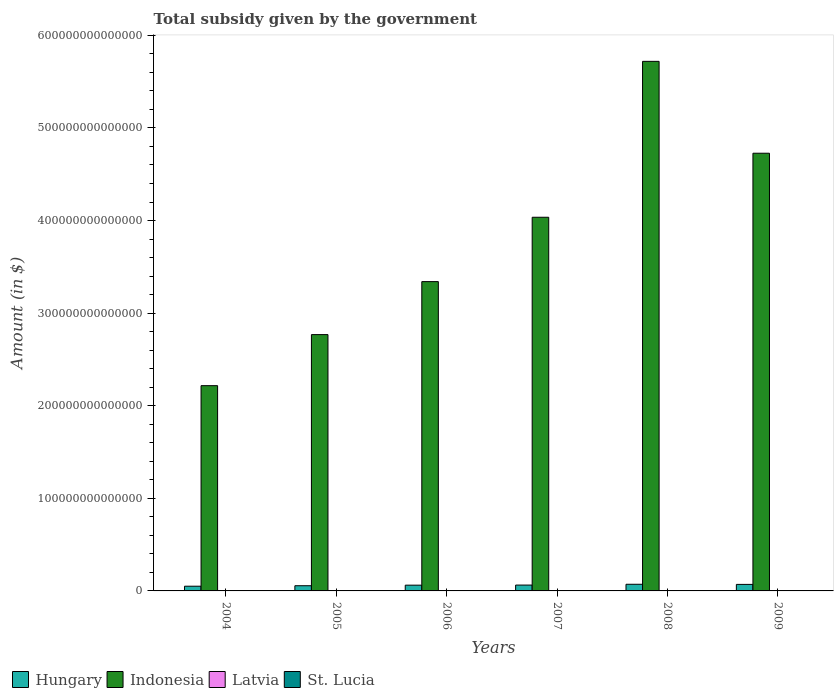How many different coloured bars are there?
Give a very brief answer. 4. Are the number of bars per tick equal to the number of legend labels?
Provide a short and direct response. Yes. How many bars are there on the 3rd tick from the left?
Ensure brevity in your answer.  4. How many bars are there on the 3rd tick from the right?
Your answer should be compact. 4. In how many cases, is the number of bars for a given year not equal to the number of legend labels?
Ensure brevity in your answer.  0. What is the total revenue collected by the government in St. Lucia in 2005?
Your answer should be compact. 9.65e+07. Across all years, what is the maximum total revenue collected by the government in St. Lucia?
Give a very brief answer. 1.28e+08. Across all years, what is the minimum total revenue collected by the government in Hungary?
Your response must be concise. 5.09e+12. In which year was the total revenue collected by the government in Indonesia maximum?
Ensure brevity in your answer.  2008. In which year was the total revenue collected by the government in Hungary minimum?
Offer a very short reply. 2004. What is the total total revenue collected by the government in St. Lucia in the graph?
Provide a succinct answer. 5.50e+08. What is the difference between the total revenue collected by the government in St. Lucia in 2004 and that in 2009?
Provide a succinct answer. -2.20e+07. What is the difference between the total revenue collected by the government in St. Lucia in 2005 and the total revenue collected by the government in Latvia in 2004?
Make the answer very short. -8.12e+08. What is the average total revenue collected by the government in Hungary per year?
Give a very brief answer. 6.24e+12. In the year 2006, what is the difference between the total revenue collected by the government in Hungary and total revenue collected by the government in Indonesia?
Give a very brief answer. -3.28e+14. What is the ratio of the total revenue collected by the government in St. Lucia in 2007 to that in 2009?
Provide a short and direct response. 0.35. What is the difference between the highest and the second highest total revenue collected by the government in Hungary?
Provide a succinct answer. 1.41e+11. What is the difference between the highest and the lowest total revenue collected by the government in St. Lucia?
Provide a succinct answer. 8.26e+07. In how many years, is the total revenue collected by the government in Latvia greater than the average total revenue collected by the government in Latvia taken over all years?
Offer a very short reply. 3. Is the sum of the total revenue collected by the government in Indonesia in 2008 and 2009 greater than the maximum total revenue collected by the government in Latvia across all years?
Give a very brief answer. Yes. What does the 2nd bar from the left in 2007 represents?
Make the answer very short. Indonesia. What does the 1st bar from the right in 2008 represents?
Ensure brevity in your answer.  St. Lucia. Is it the case that in every year, the sum of the total revenue collected by the government in Indonesia and total revenue collected by the government in Latvia is greater than the total revenue collected by the government in St. Lucia?
Provide a short and direct response. Yes. How many years are there in the graph?
Provide a succinct answer. 6. What is the difference between two consecutive major ticks on the Y-axis?
Your response must be concise. 1.00e+14. Does the graph contain any zero values?
Your answer should be compact. No. Where does the legend appear in the graph?
Offer a very short reply. Bottom left. How many legend labels are there?
Offer a very short reply. 4. What is the title of the graph?
Your answer should be very brief. Total subsidy given by the government. What is the label or title of the Y-axis?
Ensure brevity in your answer.  Amount (in $). What is the Amount (in $) of Hungary in 2004?
Keep it short and to the point. 5.09e+12. What is the Amount (in $) of Indonesia in 2004?
Keep it short and to the point. 2.22e+14. What is the Amount (in $) in Latvia in 2004?
Your response must be concise. 9.08e+08. What is the Amount (in $) of St. Lucia in 2004?
Give a very brief answer. 1.06e+08. What is the Amount (in $) in Hungary in 2005?
Your response must be concise. 5.60e+12. What is the Amount (in $) in Indonesia in 2005?
Provide a succinct answer. 2.77e+14. What is the Amount (in $) in Latvia in 2005?
Provide a succinct answer. 1.03e+09. What is the Amount (in $) in St. Lucia in 2005?
Give a very brief answer. 9.65e+07. What is the Amount (in $) in Hungary in 2006?
Make the answer very short. 6.21e+12. What is the Amount (in $) in Indonesia in 2006?
Your answer should be very brief. 3.34e+14. What is the Amount (in $) of Latvia in 2006?
Offer a very short reply. 1.28e+09. What is the Amount (in $) in St. Lucia in 2006?
Provide a succinct answer. 4.63e+07. What is the Amount (in $) of Hungary in 2007?
Ensure brevity in your answer.  6.32e+12. What is the Amount (in $) in Indonesia in 2007?
Offer a terse response. 4.04e+14. What is the Amount (in $) in Latvia in 2007?
Ensure brevity in your answer.  2.56e+09. What is the Amount (in $) of St. Lucia in 2007?
Keep it short and to the point. 4.54e+07. What is the Amount (in $) of Hungary in 2008?
Your response must be concise. 7.19e+12. What is the Amount (in $) in Indonesia in 2008?
Ensure brevity in your answer.  5.72e+14. What is the Amount (in $) of Latvia in 2008?
Offer a terse response. 3.10e+09. What is the Amount (in $) of St. Lucia in 2008?
Your answer should be very brief. 1.28e+08. What is the Amount (in $) of Hungary in 2009?
Offer a very short reply. 7.04e+12. What is the Amount (in $) of Indonesia in 2009?
Keep it short and to the point. 4.73e+14. What is the Amount (in $) in Latvia in 2009?
Your response must be concise. 3.21e+09. What is the Amount (in $) in St. Lucia in 2009?
Ensure brevity in your answer.  1.28e+08. Across all years, what is the maximum Amount (in $) of Hungary?
Provide a short and direct response. 7.19e+12. Across all years, what is the maximum Amount (in $) in Indonesia?
Provide a succinct answer. 5.72e+14. Across all years, what is the maximum Amount (in $) of Latvia?
Offer a terse response. 3.21e+09. Across all years, what is the maximum Amount (in $) of St. Lucia?
Your answer should be compact. 1.28e+08. Across all years, what is the minimum Amount (in $) in Hungary?
Offer a very short reply. 5.09e+12. Across all years, what is the minimum Amount (in $) in Indonesia?
Your answer should be compact. 2.22e+14. Across all years, what is the minimum Amount (in $) in Latvia?
Ensure brevity in your answer.  9.08e+08. Across all years, what is the minimum Amount (in $) of St. Lucia?
Ensure brevity in your answer.  4.54e+07. What is the total Amount (in $) in Hungary in the graph?
Ensure brevity in your answer.  3.75e+13. What is the total Amount (in $) of Indonesia in the graph?
Your answer should be compact. 2.28e+15. What is the total Amount (in $) of Latvia in the graph?
Ensure brevity in your answer.  1.21e+1. What is the total Amount (in $) of St. Lucia in the graph?
Your answer should be very brief. 5.50e+08. What is the difference between the Amount (in $) in Hungary in 2004 and that in 2005?
Provide a succinct answer. -5.09e+11. What is the difference between the Amount (in $) of Indonesia in 2004 and that in 2005?
Keep it short and to the point. -5.51e+13. What is the difference between the Amount (in $) in Latvia in 2004 and that in 2005?
Make the answer very short. -1.22e+08. What is the difference between the Amount (in $) of St. Lucia in 2004 and that in 2005?
Provide a short and direct response. 9.50e+06. What is the difference between the Amount (in $) of Hungary in 2004 and that in 2006?
Make the answer very short. -1.12e+12. What is the difference between the Amount (in $) of Indonesia in 2004 and that in 2006?
Your response must be concise. -1.12e+14. What is the difference between the Amount (in $) of Latvia in 2004 and that in 2006?
Your response must be concise. -3.77e+08. What is the difference between the Amount (in $) in St. Lucia in 2004 and that in 2006?
Ensure brevity in your answer.  5.97e+07. What is the difference between the Amount (in $) of Hungary in 2004 and that in 2007?
Your response must be concise. -1.23e+12. What is the difference between the Amount (in $) in Indonesia in 2004 and that in 2007?
Provide a succinct answer. -1.82e+14. What is the difference between the Amount (in $) in Latvia in 2004 and that in 2007?
Give a very brief answer. -1.65e+09. What is the difference between the Amount (in $) of St. Lucia in 2004 and that in 2007?
Your answer should be compact. 6.06e+07. What is the difference between the Amount (in $) of Hungary in 2004 and that in 2008?
Provide a succinct answer. -2.09e+12. What is the difference between the Amount (in $) of Indonesia in 2004 and that in 2008?
Your answer should be compact. -3.50e+14. What is the difference between the Amount (in $) in Latvia in 2004 and that in 2008?
Make the answer very short. -2.20e+09. What is the difference between the Amount (in $) of St. Lucia in 2004 and that in 2008?
Your response must be concise. -2.17e+07. What is the difference between the Amount (in $) in Hungary in 2004 and that in 2009?
Offer a very short reply. -1.95e+12. What is the difference between the Amount (in $) of Indonesia in 2004 and that in 2009?
Give a very brief answer. -2.51e+14. What is the difference between the Amount (in $) in Latvia in 2004 and that in 2009?
Offer a very short reply. -2.30e+09. What is the difference between the Amount (in $) in St. Lucia in 2004 and that in 2009?
Make the answer very short. -2.20e+07. What is the difference between the Amount (in $) in Hungary in 2005 and that in 2006?
Provide a short and direct response. -6.11e+11. What is the difference between the Amount (in $) of Indonesia in 2005 and that in 2006?
Your response must be concise. -5.72e+13. What is the difference between the Amount (in $) of Latvia in 2005 and that in 2006?
Give a very brief answer. -2.54e+08. What is the difference between the Amount (in $) in St. Lucia in 2005 and that in 2006?
Make the answer very short. 5.02e+07. What is the difference between the Amount (in $) of Hungary in 2005 and that in 2007?
Offer a very short reply. -7.20e+11. What is the difference between the Amount (in $) of Indonesia in 2005 and that in 2007?
Provide a short and direct response. -1.27e+14. What is the difference between the Amount (in $) in Latvia in 2005 and that in 2007?
Your answer should be compact. -1.53e+09. What is the difference between the Amount (in $) of St. Lucia in 2005 and that in 2007?
Give a very brief answer. 5.11e+07. What is the difference between the Amount (in $) in Hungary in 2005 and that in 2008?
Make the answer very short. -1.58e+12. What is the difference between the Amount (in $) of Indonesia in 2005 and that in 2008?
Your answer should be compact. -2.95e+14. What is the difference between the Amount (in $) in Latvia in 2005 and that in 2008?
Provide a succinct answer. -2.07e+09. What is the difference between the Amount (in $) in St. Lucia in 2005 and that in 2008?
Make the answer very short. -3.12e+07. What is the difference between the Amount (in $) in Hungary in 2005 and that in 2009?
Keep it short and to the point. -1.44e+12. What is the difference between the Amount (in $) in Indonesia in 2005 and that in 2009?
Offer a terse response. -1.96e+14. What is the difference between the Amount (in $) in Latvia in 2005 and that in 2009?
Make the answer very short. -2.18e+09. What is the difference between the Amount (in $) in St. Lucia in 2005 and that in 2009?
Provide a short and direct response. -3.15e+07. What is the difference between the Amount (in $) in Hungary in 2006 and that in 2007?
Ensure brevity in your answer.  -1.09e+11. What is the difference between the Amount (in $) of Indonesia in 2006 and that in 2007?
Ensure brevity in your answer.  -6.95e+13. What is the difference between the Amount (in $) of Latvia in 2006 and that in 2007?
Your answer should be very brief. -1.28e+09. What is the difference between the Amount (in $) in Hungary in 2006 and that in 2008?
Make the answer very short. -9.73e+11. What is the difference between the Amount (in $) of Indonesia in 2006 and that in 2008?
Provide a short and direct response. -2.38e+14. What is the difference between the Amount (in $) of Latvia in 2006 and that in 2008?
Your response must be concise. -1.82e+09. What is the difference between the Amount (in $) in St. Lucia in 2006 and that in 2008?
Keep it short and to the point. -8.14e+07. What is the difference between the Amount (in $) of Hungary in 2006 and that in 2009?
Provide a succinct answer. -8.32e+11. What is the difference between the Amount (in $) in Indonesia in 2006 and that in 2009?
Your response must be concise. -1.39e+14. What is the difference between the Amount (in $) in Latvia in 2006 and that in 2009?
Ensure brevity in your answer.  -1.92e+09. What is the difference between the Amount (in $) of St. Lucia in 2006 and that in 2009?
Make the answer very short. -8.17e+07. What is the difference between the Amount (in $) in Hungary in 2007 and that in 2008?
Give a very brief answer. -8.64e+11. What is the difference between the Amount (in $) of Indonesia in 2007 and that in 2008?
Ensure brevity in your answer.  -1.68e+14. What is the difference between the Amount (in $) of Latvia in 2007 and that in 2008?
Give a very brief answer. -5.41e+08. What is the difference between the Amount (in $) in St. Lucia in 2007 and that in 2008?
Provide a succinct answer. -8.23e+07. What is the difference between the Amount (in $) in Hungary in 2007 and that in 2009?
Provide a succinct answer. -7.23e+11. What is the difference between the Amount (in $) in Indonesia in 2007 and that in 2009?
Your response must be concise. -6.92e+13. What is the difference between the Amount (in $) of Latvia in 2007 and that in 2009?
Make the answer very short. -6.46e+08. What is the difference between the Amount (in $) of St. Lucia in 2007 and that in 2009?
Make the answer very short. -8.26e+07. What is the difference between the Amount (in $) in Hungary in 2008 and that in 2009?
Offer a terse response. 1.41e+11. What is the difference between the Amount (in $) of Indonesia in 2008 and that in 2009?
Offer a very short reply. 9.92e+13. What is the difference between the Amount (in $) of Latvia in 2008 and that in 2009?
Make the answer very short. -1.05e+08. What is the difference between the Amount (in $) of Hungary in 2004 and the Amount (in $) of Indonesia in 2005?
Make the answer very short. -2.72e+14. What is the difference between the Amount (in $) in Hungary in 2004 and the Amount (in $) in Latvia in 2005?
Keep it short and to the point. 5.09e+12. What is the difference between the Amount (in $) in Hungary in 2004 and the Amount (in $) in St. Lucia in 2005?
Make the answer very short. 5.09e+12. What is the difference between the Amount (in $) in Indonesia in 2004 and the Amount (in $) in Latvia in 2005?
Keep it short and to the point. 2.22e+14. What is the difference between the Amount (in $) in Indonesia in 2004 and the Amount (in $) in St. Lucia in 2005?
Give a very brief answer. 2.22e+14. What is the difference between the Amount (in $) in Latvia in 2004 and the Amount (in $) in St. Lucia in 2005?
Give a very brief answer. 8.12e+08. What is the difference between the Amount (in $) of Hungary in 2004 and the Amount (in $) of Indonesia in 2006?
Offer a very short reply. -3.29e+14. What is the difference between the Amount (in $) in Hungary in 2004 and the Amount (in $) in Latvia in 2006?
Your answer should be very brief. 5.09e+12. What is the difference between the Amount (in $) of Hungary in 2004 and the Amount (in $) of St. Lucia in 2006?
Keep it short and to the point. 5.09e+12. What is the difference between the Amount (in $) of Indonesia in 2004 and the Amount (in $) of Latvia in 2006?
Keep it short and to the point. 2.22e+14. What is the difference between the Amount (in $) of Indonesia in 2004 and the Amount (in $) of St. Lucia in 2006?
Your answer should be very brief. 2.22e+14. What is the difference between the Amount (in $) in Latvia in 2004 and the Amount (in $) in St. Lucia in 2006?
Provide a succinct answer. 8.62e+08. What is the difference between the Amount (in $) of Hungary in 2004 and the Amount (in $) of Indonesia in 2007?
Give a very brief answer. -3.98e+14. What is the difference between the Amount (in $) in Hungary in 2004 and the Amount (in $) in Latvia in 2007?
Offer a terse response. 5.09e+12. What is the difference between the Amount (in $) of Hungary in 2004 and the Amount (in $) of St. Lucia in 2007?
Offer a very short reply. 5.09e+12. What is the difference between the Amount (in $) in Indonesia in 2004 and the Amount (in $) in Latvia in 2007?
Offer a very short reply. 2.22e+14. What is the difference between the Amount (in $) of Indonesia in 2004 and the Amount (in $) of St. Lucia in 2007?
Your answer should be very brief. 2.22e+14. What is the difference between the Amount (in $) in Latvia in 2004 and the Amount (in $) in St. Lucia in 2007?
Your answer should be compact. 8.63e+08. What is the difference between the Amount (in $) in Hungary in 2004 and the Amount (in $) in Indonesia in 2008?
Your response must be concise. -5.67e+14. What is the difference between the Amount (in $) of Hungary in 2004 and the Amount (in $) of Latvia in 2008?
Offer a very short reply. 5.09e+12. What is the difference between the Amount (in $) in Hungary in 2004 and the Amount (in $) in St. Lucia in 2008?
Your response must be concise. 5.09e+12. What is the difference between the Amount (in $) of Indonesia in 2004 and the Amount (in $) of Latvia in 2008?
Make the answer very short. 2.22e+14. What is the difference between the Amount (in $) in Indonesia in 2004 and the Amount (in $) in St. Lucia in 2008?
Provide a short and direct response. 2.22e+14. What is the difference between the Amount (in $) in Latvia in 2004 and the Amount (in $) in St. Lucia in 2008?
Keep it short and to the point. 7.80e+08. What is the difference between the Amount (in $) in Hungary in 2004 and the Amount (in $) in Indonesia in 2009?
Provide a short and direct response. -4.68e+14. What is the difference between the Amount (in $) in Hungary in 2004 and the Amount (in $) in Latvia in 2009?
Make the answer very short. 5.09e+12. What is the difference between the Amount (in $) of Hungary in 2004 and the Amount (in $) of St. Lucia in 2009?
Your answer should be compact. 5.09e+12. What is the difference between the Amount (in $) of Indonesia in 2004 and the Amount (in $) of Latvia in 2009?
Provide a succinct answer. 2.22e+14. What is the difference between the Amount (in $) of Indonesia in 2004 and the Amount (in $) of St. Lucia in 2009?
Offer a very short reply. 2.22e+14. What is the difference between the Amount (in $) in Latvia in 2004 and the Amount (in $) in St. Lucia in 2009?
Your response must be concise. 7.80e+08. What is the difference between the Amount (in $) in Hungary in 2005 and the Amount (in $) in Indonesia in 2006?
Make the answer very short. -3.28e+14. What is the difference between the Amount (in $) of Hungary in 2005 and the Amount (in $) of Latvia in 2006?
Keep it short and to the point. 5.60e+12. What is the difference between the Amount (in $) of Hungary in 2005 and the Amount (in $) of St. Lucia in 2006?
Make the answer very short. 5.60e+12. What is the difference between the Amount (in $) of Indonesia in 2005 and the Amount (in $) of Latvia in 2006?
Ensure brevity in your answer.  2.77e+14. What is the difference between the Amount (in $) in Indonesia in 2005 and the Amount (in $) in St. Lucia in 2006?
Keep it short and to the point. 2.77e+14. What is the difference between the Amount (in $) in Latvia in 2005 and the Amount (in $) in St. Lucia in 2006?
Offer a very short reply. 9.84e+08. What is the difference between the Amount (in $) of Hungary in 2005 and the Amount (in $) of Indonesia in 2007?
Keep it short and to the point. -3.98e+14. What is the difference between the Amount (in $) of Hungary in 2005 and the Amount (in $) of Latvia in 2007?
Provide a succinct answer. 5.60e+12. What is the difference between the Amount (in $) in Hungary in 2005 and the Amount (in $) in St. Lucia in 2007?
Offer a terse response. 5.60e+12. What is the difference between the Amount (in $) in Indonesia in 2005 and the Amount (in $) in Latvia in 2007?
Your response must be concise. 2.77e+14. What is the difference between the Amount (in $) of Indonesia in 2005 and the Amount (in $) of St. Lucia in 2007?
Your answer should be compact. 2.77e+14. What is the difference between the Amount (in $) of Latvia in 2005 and the Amount (in $) of St. Lucia in 2007?
Ensure brevity in your answer.  9.85e+08. What is the difference between the Amount (in $) in Hungary in 2005 and the Amount (in $) in Indonesia in 2008?
Your answer should be compact. -5.66e+14. What is the difference between the Amount (in $) in Hungary in 2005 and the Amount (in $) in Latvia in 2008?
Your response must be concise. 5.60e+12. What is the difference between the Amount (in $) of Hungary in 2005 and the Amount (in $) of St. Lucia in 2008?
Make the answer very short. 5.60e+12. What is the difference between the Amount (in $) of Indonesia in 2005 and the Amount (in $) of Latvia in 2008?
Offer a terse response. 2.77e+14. What is the difference between the Amount (in $) of Indonesia in 2005 and the Amount (in $) of St. Lucia in 2008?
Give a very brief answer. 2.77e+14. What is the difference between the Amount (in $) in Latvia in 2005 and the Amount (in $) in St. Lucia in 2008?
Your response must be concise. 9.03e+08. What is the difference between the Amount (in $) in Hungary in 2005 and the Amount (in $) in Indonesia in 2009?
Offer a very short reply. -4.67e+14. What is the difference between the Amount (in $) in Hungary in 2005 and the Amount (in $) in Latvia in 2009?
Ensure brevity in your answer.  5.60e+12. What is the difference between the Amount (in $) of Hungary in 2005 and the Amount (in $) of St. Lucia in 2009?
Your answer should be compact. 5.60e+12. What is the difference between the Amount (in $) of Indonesia in 2005 and the Amount (in $) of Latvia in 2009?
Provide a succinct answer. 2.77e+14. What is the difference between the Amount (in $) in Indonesia in 2005 and the Amount (in $) in St. Lucia in 2009?
Your answer should be compact. 2.77e+14. What is the difference between the Amount (in $) in Latvia in 2005 and the Amount (in $) in St. Lucia in 2009?
Offer a terse response. 9.02e+08. What is the difference between the Amount (in $) in Hungary in 2006 and the Amount (in $) in Indonesia in 2007?
Your answer should be very brief. -3.97e+14. What is the difference between the Amount (in $) in Hungary in 2006 and the Amount (in $) in Latvia in 2007?
Give a very brief answer. 6.21e+12. What is the difference between the Amount (in $) of Hungary in 2006 and the Amount (in $) of St. Lucia in 2007?
Your answer should be compact. 6.21e+12. What is the difference between the Amount (in $) in Indonesia in 2006 and the Amount (in $) in Latvia in 2007?
Provide a short and direct response. 3.34e+14. What is the difference between the Amount (in $) in Indonesia in 2006 and the Amount (in $) in St. Lucia in 2007?
Your answer should be compact. 3.34e+14. What is the difference between the Amount (in $) of Latvia in 2006 and the Amount (in $) of St. Lucia in 2007?
Your answer should be compact. 1.24e+09. What is the difference between the Amount (in $) of Hungary in 2006 and the Amount (in $) of Indonesia in 2008?
Offer a very short reply. -5.66e+14. What is the difference between the Amount (in $) of Hungary in 2006 and the Amount (in $) of Latvia in 2008?
Provide a succinct answer. 6.21e+12. What is the difference between the Amount (in $) in Hungary in 2006 and the Amount (in $) in St. Lucia in 2008?
Make the answer very short. 6.21e+12. What is the difference between the Amount (in $) in Indonesia in 2006 and the Amount (in $) in Latvia in 2008?
Ensure brevity in your answer.  3.34e+14. What is the difference between the Amount (in $) in Indonesia in 2006 and the Amount (in $) in St. Lucia in 2008?
Provide a succinct answer. 3.34e+14. What is the difference between the Amount (in $) in Latvia in 2006 and the Amount (in $) in St. Lucia in 2008?
Give a very brief answer. 1.16e+09. What is the difference between the Amount (in $) in Hungary in 2006 and the Amount (in $) in Indonesia in 2009?
Keep it short and to the point. -4.66e+14. What is the difference between the Amount (in $) in Hungary in 2006 and the Amount (in $) in Latvia in 2009?
Offer a very short reply. 6.21e+12. What is the difference between the Amount (in $) in Hungary in 2006 and the Amount (in $) in St. Lucia in 2009?
Your response must be concise. 6.21e+12. What is the difference between the Amount (in $) in Indonesia in 2006 and the Amount (in $) in Latvia in 2009?
Provide a succinct answer. 3.34e+14. What is the difference between the Amount (in $) in Indonesia in 2006 and the Amount (in $) in St. Lucia in 2009?
Make the answer very short. 3.34e+14. What is the difference between the Amount (in $) in Latvia in 2006 and the Amount (in $) in St. Lucia in 2009?
Keep it short and to the point. 1.16e+09. What is the difference between the Amount (in $) in Hungary in 2007 and the Amount (in $) in Indonesia in 2008?
Your answer should be very brief. -5.66e+14. What is the difference between the Amount (in $) of Hungary in 2007 and the Amount (in $) of Latvia in 2008?
Keep it short and to the point. 6.32e+12. What is the difference between the Amount (in $) of Hungary in 2007 and the Amount (in $) of St. Lucia in 2008?
Keep it short and to the point. 6.32e+12. What is the difference between the Amount (in $) of Indonesia in 2007 and the Amount (in $) of Latvia in 2008?
Give a very brief answer. 4.04e+14. What is the difference between the Amount (in $) of Indonesia in 2007 and the Amount (in $) of St. Lucia in 2008?
Keep it short and to the point. 4.04e+14. What is the difference between the Amount (in $) in Latvia in 2007 and the Amount (in $) in St. Lucia in 2008?
Provide a short and direct response. 2.43e+09. What is the difference between the Amount (in $) of Hungary in 2007 and the Amount (in $) of Indonesia in 2009?
Your answer should be very brief. -4.66e+14. What is the difference between the Amount (in $) in Hungary in 2007 and the Amount (in $) in Latvia in 2009?
Ensure brevity in your answer.  6.32e+12. What is the difference between the Amount (in $) in Hungary in 2007 and the Amount (in $) in St. Lucia in 2009?
Give a very brief answer. 6.32e+12. What is the difference between the Amount (in $) of Indonesia in 2007 and the Amount (in $) of Latvia in 2009?
Provide a short and direct response. 4.04e+14. What is the difference between the Amount (in $) in Indonesia in 2007 and the Amount (in $) in St. Lucia in 2009?
Your answer should be compact. 4.04e+14. What is the difference between the Amount (in $) in Latvia in 2007 and the Amount (in $) in St. Lucia in 2009?
Keep it short and to the point. 2.43e+09. What is the difference between the Amount (in $) in Hungary in 2008 and the Amount (in $) in Indonesia in 2009?
Provide a short and direct response. -4.65e+14. What is the difference between the Amount (in $) in Hungary in 2008 and the Amount (in $) in Latvia in 2009?
Your answer should be compact. 7.18e+12. What is the difference between the Amount (in $) of Hungary in 2008 and the Amount (in $) of St. Lucia in 2009?
Ensure brevity in your answer.  7.19e+12. What is the difference between the Amount (in $) of Indonesia in 2008 and the Amount (in $) of Latvia in 2009?
Provide a short and direct response. 5.72e+14. What is the difference between the Amount (in $) of Indonesia in 2008 and the Amount (in $) of St. Lucia in 2009?
Provide a succinct answer. 5.72e+14. What is the difference between the Amount (in $) of Latvia in 2008 and the Amount (in $) of St. Lucia in 2009?
Ensure brevity in your answer.  2.98e+09. What is the average Amount (in $) in Hungary per year?
Ensure brevity in your answer.  6.24e+12. What is the average Amount (in $) in Indonesia per year?
Offer a terse response. 3.80e+14. What is the average Amount (in $) of Latvia per year?
Keep it short and to the point. 2.02e+09. What is the average Amount (in $) in St. Lucia per year?
Offer a very short reply. 9.16e+07. In the year 2004, what is the difference between the Amount (in $) in Hungary and Amount (in $) in Indonesia?
Your answer should be compact. -2.17e+14. In the year 2004, what is the difference between the Amount (in $) in Hungary and Amount (in $) in Latvia?
Offer a very short reply. 5.09e+12. In the year 2004, what is the difference between the Amount (in $) in Hungary and Amount (in $) in St. Lucia?
Keep it short and to the point. 5.09e+12. In the year 2004, what is the difference between the Amount (in $) in Indonesia and Amount (in $) in Latvia?
Give a very brief answer. 2.22e+14. In the year 2004, what is the difference between the Amount (in $) in Indonesia and Amount (in $) in St. Lucia?
Ensure brevity in your answer.  2.22e+14. In the year 2004, what is the difference between the Amount (in $) in Latvia and Amount (in $) in St. Lucia?
Offer a very short reply. 8.02e+08. In the year 2005, what is the difference between the Amount (in $) of Hungary and Amount (in $) of Indonesia?
Ensure brevity in your answer.  -2.71e+14. In the year 2005, what is the difference between the Amount (in $) of Hungary and Amount (in $) of Latvia?
Provide a succinct answer. 5.60e+12. In the year 2005, what is the difference between the Amount (in $) of Hungary and Amount (in $) of St. Lucia?
Provide a succinct answer. 5.60e+12. In the year 2005, what is the difference between the Amount (in $) of Indonesia and Amount (in $) of Latvia?
Offer a terse response. 2.77e+14. In the year 2005, what is the difference between the Amount (in $) in Indonesia and Amount (in $) in St. Lucia?
Keep it short and to the point. 2.77e+14. In the year 2005, what is the difference between the Amount (in $) in Latvia and Amount (in $) in St. Lucia?
Your response must be concise. 9.34e+08. In the year 2006, what is the difference between the Amount (in $) in Hungary and Amount (in $) in Indonesia?
Give a very brief answer. -3.28e+14. In the year 2006, what is the difference between the Amount (in $) in Hungary and Amount (in $) in Latvia?
Keep it short and to the point. 6.21e+12. In the year 2006, what is the difference between the Amount (in $) in Hungary and Amount (in $) in St. Lucia?
Provide a short and direct response. 6.21e+12. In the year 2006, what is the difference between the Amount (in $) in Indonesia and Amount (in $) in Latvia?
Your response must be concise. 3.34e+14. In the year 2006, what is the difference between the Amount (in $) of Indonesia and Amount (in $) of St. Lucia?
Make the answer very short. 3.34e+14. In the year 2006, what is the difference between the Amount (in $) of Latvia and Amount (in $) of St. Lucia?
Provide a short and direct response. 1.24e+09. In the year 2007, what is the difference between the Amount (in $) of Hungary and Amount (in $) of Indonesia?
Offer a terse response. -3.97e+14. In the year 2007, what is the difference between the Amount (in $) of Hungary and Amount (in $) of Latvia?
Your answer should be very brief. 6.32e+12. In the year 2007, what is the difference between the Amount (in $) of Hungary and Amount (in $) of St. Lucia?
Give a very brief answer. 6.32e+12. In the year 2007, what is the difference between the Amount (in $) in Indonesia and Amount (in $) in Latvia?
Your answer should be compact. 4.04e+14. In the year 2007, what is the difference between the Amount (in $) in Indonesia and Amount (in $) in St. Lucia?
Your answer should be compact. 4.04e+14. In the year 2007, what is the difference between the Amount (in $) in Latvia and Amount (in $) in St. Lucia?
Keep it short and to the point. 2.52e+09. In the year 2008, what is the difference between the Amount (in $) of Hungary and Amount (in $) of Indonesia?
Ensure brevity in your answer.  -5.65e+14. In the year 2008, what is the difference between the Amount (in $) in Hungary and Amount (in $) in Latvia?
Provide a succinct answer. 7.18e+12. In the year 2008, what is the difference between the Amount (in $) in Hungary and Amount (in $) in St. Lucia?
Keep it short and to the point. 7.19e+12. In the year 2008, what is the difference between the Amount (in $) in Indonesia and Amount (in $) in Latvia?
Your answer should be very brief. 5.72e+14. In the year 2008, what is the difference between the Amount (in $) in Indonesia and Amount (in $) in St. Lucia?
Provide a succinct answer. 5.72e+14. In the year 2008, what is the difference between the Amount (in $) of Latvia and Amount (in $) of St. Lucia?
Keep it short and to the point. 2.98e+09. In the year 2009, what is the difference between the Amount (in $) of Hungary and Amount (in $) of Indonesia?
Make the answer very short. -4.66e+14. In the year 2009, what is the difference between the Amount (in $) of Hungary and Amount (in $) of Latvia?
Provide a short and direct response. 7.04e+12. In the year 2009, what is the difference between the Amount (in $) of Hungary and Amount (in $) of St. Lucia?
Give a very brief answer. 7.04e+12. In the year 2009, what is the difference between the Amount (in $) in Indonesia and Amount (in $) in Latvia?
Your response must be concise. 4.73e+14. In the year 2009, what is the difference between the Amount (in $) of Indonesia and Amount (in $) of St. Lucia?
Offer a terse response. 4.73e+14. In the year 2009, what is the difference between the Amount (in $) in Latvia and Amount (in $) in St. Lucia?
Provide a short and direct response. 3.08e+09. What is the ratio of the Amount (in $) of Indonesia in 2004 to that in 2005?
Ensure brevity in your answer.  0.8. What is the ratio of the Amount (in $) of Latvia in 2004 to that in 2005?
Ensure brevity in your answer.  0.88. What is the ratio of the Amount (in $) of St. Lucia in 2004 to that in 2005?
Make the answer very short. 1.1. What is the ratio of the Amount (in $) in Hungary in 2004 to that in 2006?
Offer a very short reply. 0.82. What is the ratio of the Amount (in $) in Indonesia in 2004 to that in 2006?
Provide a short and direct response. 0.66. What is the ratio of the Amount (in $) in Latvia in 2004 to that in 2006?
Provide a short and direct response. 0.71. What is the ratio of the Amount (in $) in St. Lucia in 2004 to that in 2006?
Give a very brief answer. 2.29. What is the ratio of the Amount (in $) in Hungary in 2004 to that in 2007?
Give a very brief answer. 0.81. What is the ratio of the Amount (in $) of Indonesia in 2004 to that in 2007?
Offer a terse response. 0.55. What is the ratio of the Amount (in $) in Latvia in 2004 to that in 2007?
Give a very brief answer. 0.35. What is the ratio of the Amount (in $) of St. Lucia in 2004 to that in 2007?
Ensure brevity in your answer.  2.33. What is the ratio of the Amount (in $) of Hungary in 2004 to that in 2008?
Ensure brevity in your answer.  0.71. What is the ratio of the Amount (in $) in Indonesia in 2004 to that in 2008?
Offer a terse response. 0.39. What is the ratio of the Amount (in $) of Latvia in 2004 to that in 2008?
Provide a succinct answer. 0.29. What is the ratio of the Amount (in $) of St. Lucia in 2004 to that in 2008?
Provide a succinct answer. 0.83. What is the ratio of the Amount (in $) of Hungary in 2004 to that in 2009?
Offer a very short reply. 0.72. What is the ratio of the Amount (in $) in Indonesia in 2004 to that in 2009?
Your answer should be compact. 0.47. What is the ratio of the Amount (in $) in Latvia in 2004 to that in 2009?
Keep it short and to the point. 0.28. What is the ratio of the Amount (in $) in St. Lucia in 2004 to that in 2009?
Your answer should be compact. 0.83. What is the ratio of the Amount (in $) in Hungary in 2005 to that in 2006?
Make the answer very short. 0.9. What is the ratio of the Amount (in $) of Indonesia in 2005 to that in 2006?
Offer a terse response. 0.83. What is the ratio of the Amount (in $) of Latvia in 2005 to that in 2006?
Offer a very short reply. 0.8. What is the ratio of the Amount (in $) in St. Lucia in 2005 to that in 2006?
Give a very brief answer. 2.08. What is the ratio of the Amount (in $) in Hungary in 2005 to that in 2007?
Your answer should be compact. 0.89. What is the ratio of the Amount (in $) in Indonesia in 2005 to that in 2007?
Your answer should be very brief. 0.69. What is the ratio of the Amount (in $) in Latvia in 2005 to that in 2007?
Your answer should be very brief. 0.4. What is the ratio of the Amount (in $) of St. Lucia in 2005 to that in 2007?
Keep it short and to the point. 2.13. What is the ratio of the Amount (in $) in Hungary in 2005 to that in 2008?
Offer a terse response. 0.78. What is the ratio of the Amount (in $) in Indonesia in 2005 to that in 2008?
Ensure brevity in your answer.  0.48. What is the ratio of the Amount (in $) of Latvia in 2005 to that in 2008?
Offer a terse response. 0.33. What is the ratio of the Amount (in $) of St. Lucia in 2005 to that in 2008?
Offer a very short reply. 0.76. What is the ratio of the Amount (in $) in Hungary in 2005 to that in 2009?
Provide a short and direct response. 0.8. What is the ratio of the Amount (in $) in Indonesia in 2005 to that in 2009?
Make the answer very short. 0.59. What is the ratio of the Amount (in $) of Latvia in 2005 to that in 2009?
Ensure brevity in your answer.  0.32. What is the ratio of the Amount (in $) in St. Lucia in 2005 to that in 2009?
Your response must be concise. 0.75. What is the ratio of the Amount (in $) in Hungary in 2006 to that in 2007?
Your answer should be very brief. 0.98. What is the ratio of the Amount (in $) in Indonesia in 2006 to that in 2007?
Your answer should be very brief. 0.83. What is the ratio of the Amount (in $) of Latvia in 2006 to that in 2007?
Your response must be concise. 0.5. What is the ratio of the Amount (in $) of St. Lucia in 2006 to that in 2007?
Provide a succinct answer. 1.02. What is the ratio of the Amount (in $) in Hungary in 2006 to that in 2008?
Your answer should be compact. 0.86. What is the ratio of the Amount (in $) of Indonesia in 2006 to that in 2008?
Ensure brevity in your answer.  0.58. What is the ratio of the Amount (in $) in Latvia in 2006 to that in 2008?
Offer a very short reply. 0.41. What is the ratio of the Amount (in $) in St. Lucia in 2006 to that in 2008?
Make the answer very short. 0.36. What is the ratio of the Amount (in $) in Hungary in 2006 to that in 2009?
Ensure brevity in your answer.  0.88. What is the ratio of the Amount (in $) in Indonesia in 2006 to that in 2009?
Make the answer very short. 0.71. What is the ratio of the Amount (in $) in Latvia in 2006 to that in 2009?
Ensure brevity in your answer.  0.4. What is the ratio of the Amount (in $) in St. Lucia in 2006 to that in 2009?
Your answer should be compact. 0.36. What is the ratio of the Amount (in $) of Hungary in 2007 to that in 2008?
Provide a succinct answer. 0.88. What is the ratio of the Amount (in $) in Indonesia in 2007 to that in 2008?
Offer a terse response. 0.71. What is the ratio of the Amount (in $) in Latvia in 2007 to that in 2008?
Make the answer very short. 0.83. What is the ratio of the Amount (in $) of St. Lucia in 2007 to that in 2008?
Provide a short and direct response. 0.36. What is the ratio of the Amount (in $) of Hungary in 2007 to that in 2009?
Provide a succinct answer. 0.9. What is the ratio of the Amount (in $) of Indonesia in 2007 to that in 2009?
Provide a succinct answer. 0.85. What is the ratio of the Amount (in $) in Latvia in 2007 to that in 2009?
Ensure brevity in your answer.  0.8. What is the ratio of the Amount (in $) of St. Lucia in 2007 to that in 2009?
Ensure brevity in your answer.  0.35. What is the ratio of the Amount (in $) of Hungary in 2008 to that in 2009?
Your answer should be compact. 1.02. What is the ratio of the Amount (in $) in Indonesia in 2008 to that in 2009?
Make the answer very short. 1.21. What is the ratio of the Amount (in $) of Latvia in 2008 to that in 2009?
Provide a short and direct response. 0.97. What is the ratio of the Amount (in $) of St. Lucia in 2008 to that in 2009?
Offer a terse response. 1. What is the difference between the highest and the second highest Amount (in $) in Hungary?
Offer a terse response. 1.41e+11. What is the difference between the highest and the second highest Amount (in $) in Indonesia?
Offer a terse response. 9.92e+13. What is the difference between the highest and the second highest Amount (in $) in Latvia?
Provide a short and direct response. 1.05e+08. What is the difference between the highest and the second highest Amount (in $) of St. Lucia?
Offer a terse response. 3.00e+05. What is the difference between the highest and the lowest Amount (in $) of Hungary?
Your answer should be very brief. 2.09e+12. What is the difference between the highest and the lowest Amount (in $) of Indonesia?
Provide a short and direct response. 3.50e+14. What is the difference between the highest and the lowest Amount (in $) in Latvia?
Make the answer very short. 2.30e+09. What is the difference between the highest and the lowest Amount (in $) in St. Lucia?
Offer a terse response. 8.26e+07. 